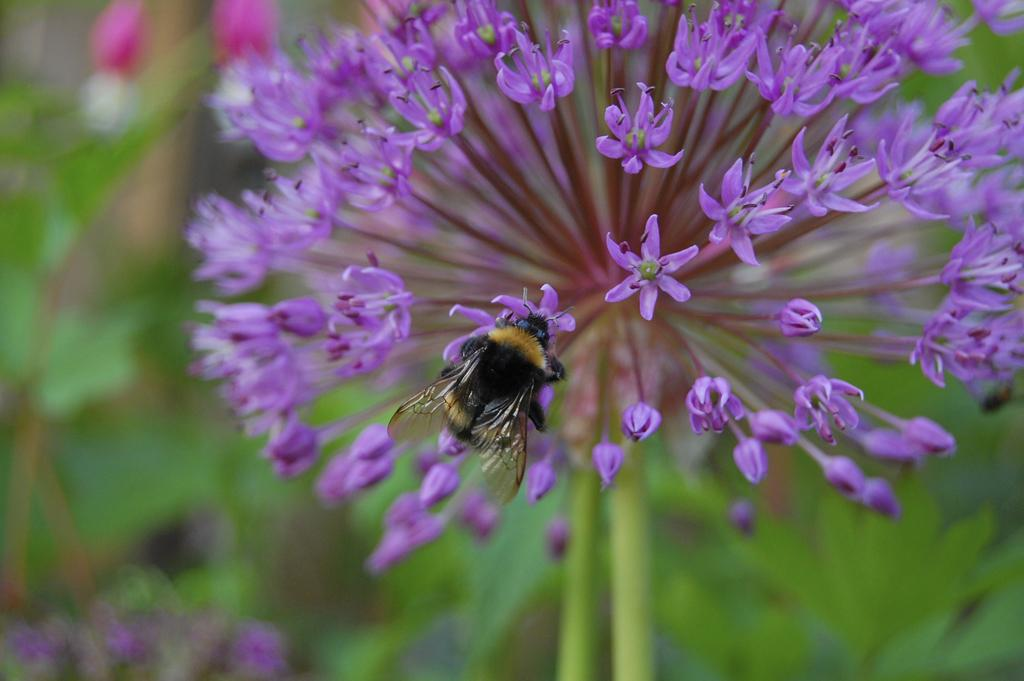What is on the flower in the image? There is an insect on a flower in the image. What type of plants are visible in the image? There are flowers and flower buds in the image. How would you describe the background of the image? The background of the image is blurry. How many spiders are crawling on the branch in the image? There is no branch or spiders present in the image. 